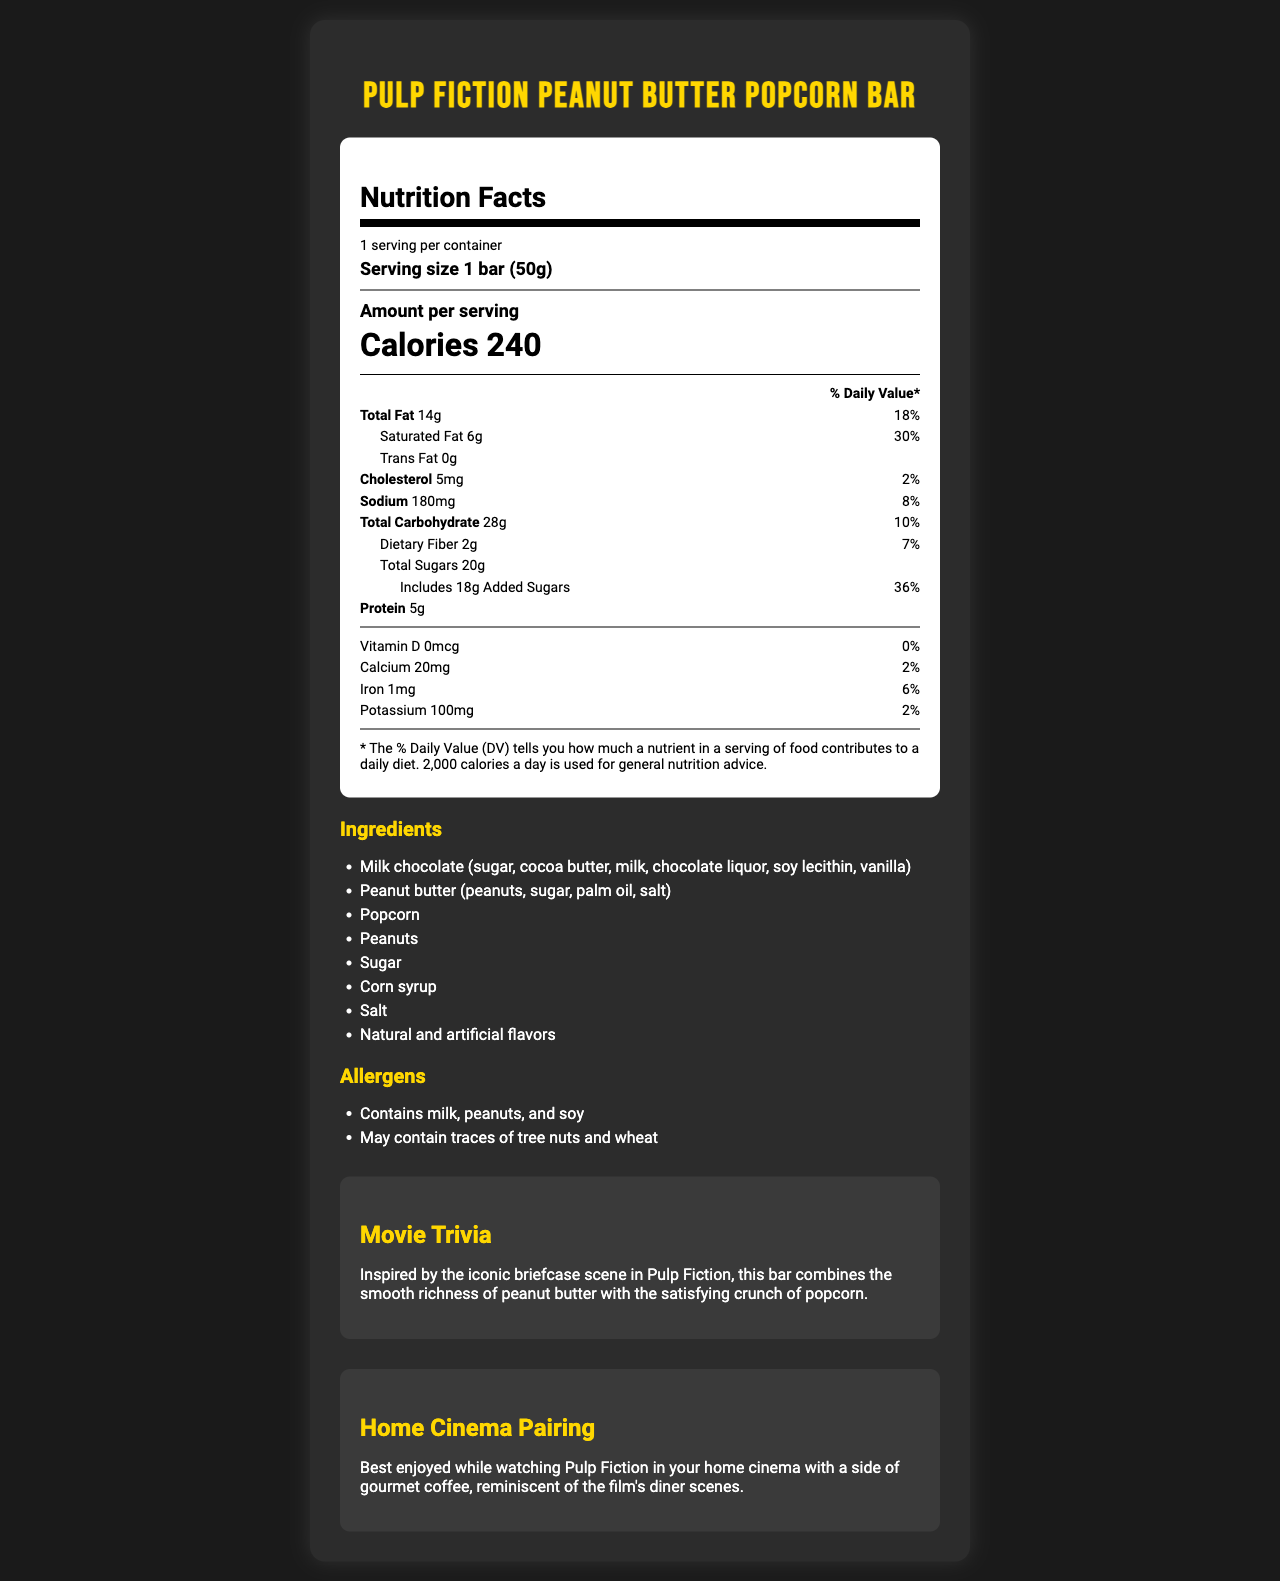what is the serving size of the "Pulp Fiction Peanut Butter Popcorn Bar"? It is clearly mentioned on the label as "Serving size: 1 bar (50g)".
Answer: 1 bar (50g) how many calories are there per serving? The label states "Calories: 240" for one serving.
Answer: 240 what percentage of the daily value is the total fat? The label lists "Total Fat: 14g" and a corresponding daily value percentage of 18%.
Answer: 18% which flavored ingredient is most prominent in the movie trivia? The movie trivia mentions combining "the smooth richness of peanut butter with the satisfying crunch of popcorn."
Answer: Peanut butter and popcorn what is the total sugar content in grams? The label specifies "Total Sugars: 20g".
Answer: 20g how much sodium does the bar contain? Sodium content is listed as 180mg on the label.
Answer: 180mg which vitamins and minerals are mentioned on the nutrition label? The nutrition label lists these specific vitamins and minerals along with their amounts and daily values.
Answer: Vitamin D, Calcium, Iron, Potassium what type of movie should you pair this chocolate bar with according to the label? The home cinema pairing section suggests enjoying the bar while watching "Pulp Fiction" in your home cinema.
Answer: Pulp Fiction which of the following allergens are contained in the bar? A. Milk B. Tree Nuts C. Soy D. Wheat The allergens list includes milk and soy. It also mentions potential traces of tree nuts and wheat.
Answer: A and C what ingredient combination is highlighted in the movie trivia? A. Dark Chocolate and Almonds B. Milk Chocolate and Peanuts C. Peanut Butter and Popcorn D. Peanuts and Salt The movie trivia highlights "peanut butter and popcorn."
Answer: C is there any fiber content in the bar? The label lists "Dietary Fiber: 2g," indicating the bar does contain fiber.
Answer: Yes could the label provide information on whether the product is gluten-free? The label mentions that the product may contain traces of wheat, but it doesn't explicitly state whether it's gluten-free.
Answer: Not enough information summarize the main content of the document. The document focuses on presenting all relevant nutrition information for the chocolate bar, highlighting its unique flavor combination inspired by "Pulp Fiction," and suggesting a movie pairing for an optimal viewing and snacking experience.
Answer: The document provides a detailed nutrition facts label for the "Pulp Fiction Peanut Butter Popcorn Bar." It includes the serving size, calories, nutrient content (such as fats, cholesterol, sodium, carbohydrates, sugars, and protein), vitamins and minerals, and ingredients used in the bar. It also lists potential allergens and offers movie-related trivia and a home cinema pairing suggestion to enhance the enjoyment of the product. 